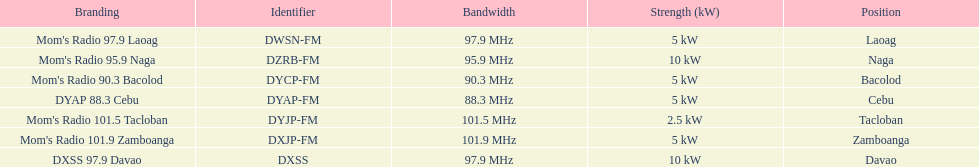What are the total number of radio stations on this list? 7. 